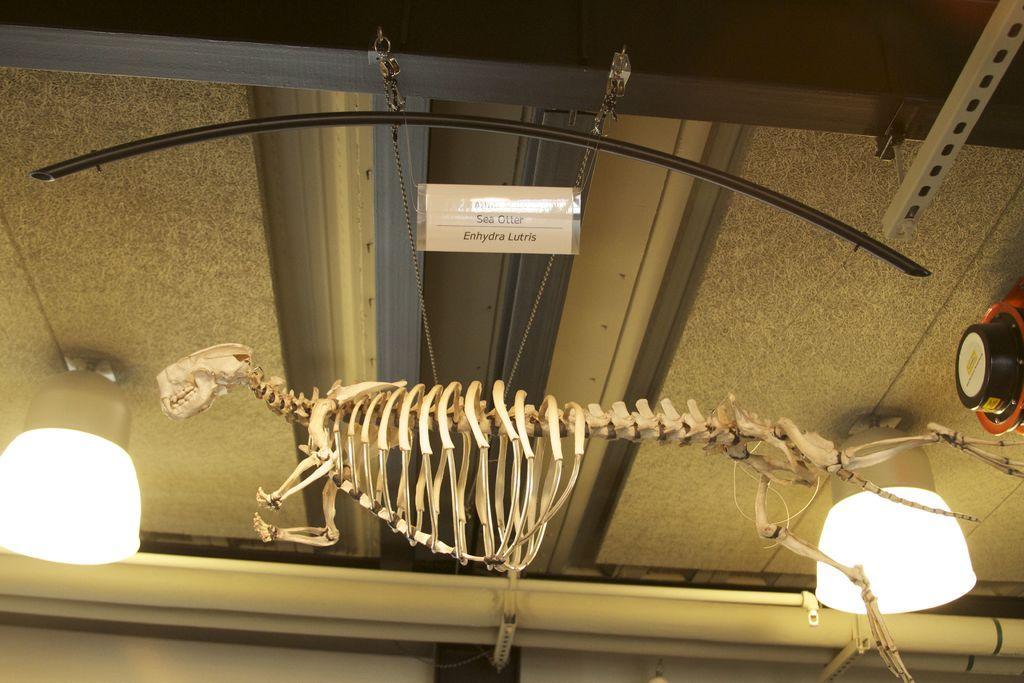In one or two sentences, can you explain what this image depicts? In this image I see the skeleton of an animal and I see the lights and I see that this skeleton is hanging and I see something is written on this paper and I see a thing over here and I see the ceiling. 